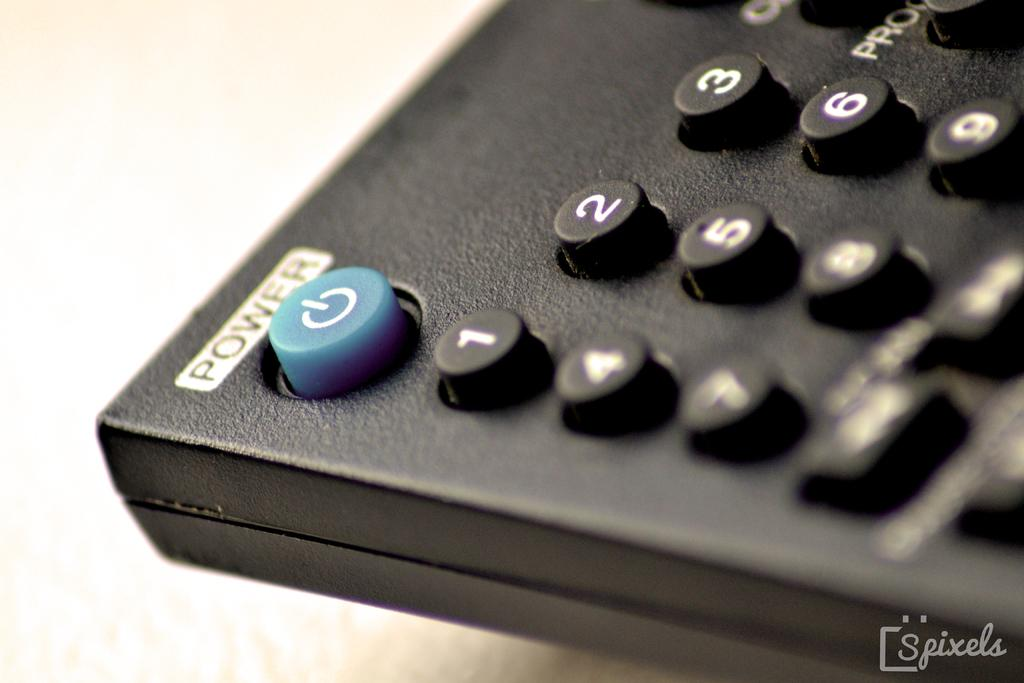Provide a one-sentence caption for the provided image. A television remote control with a blue power button with the power label at the top. 